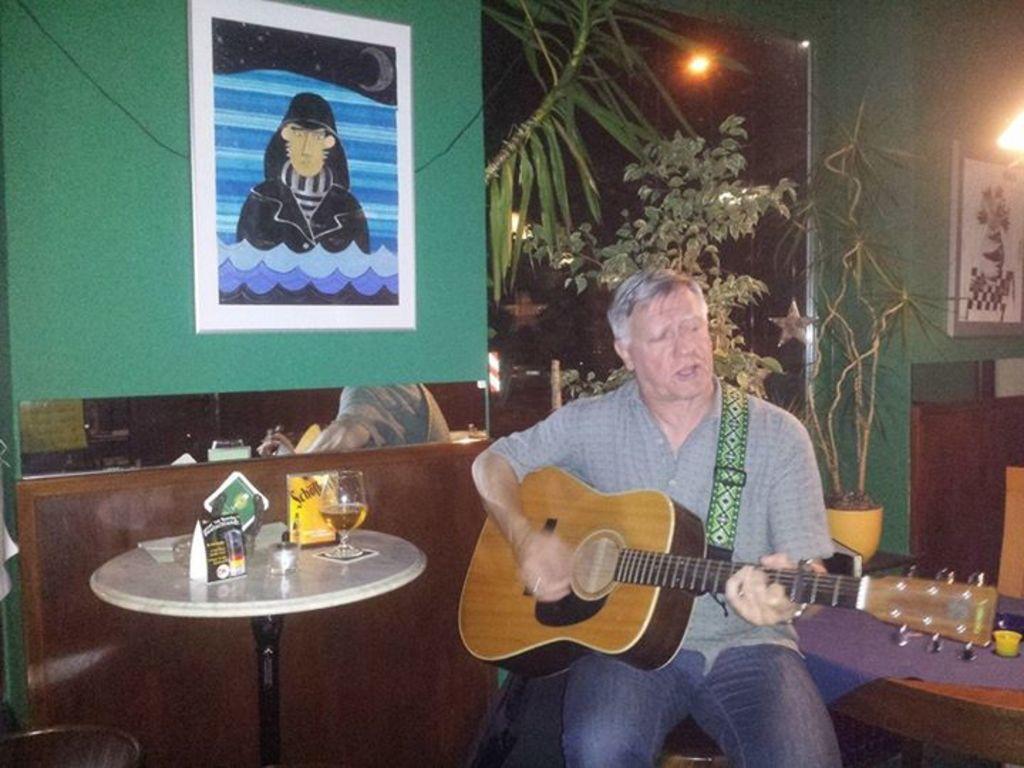Could you give a brief overview of what you see in this image? On the background we can see a wall painted with green colour and also a photo frames. These are plants and lights. Here we can see one man sitting on a chair and playing guitar. On the table we can see glass of drink, boards. 